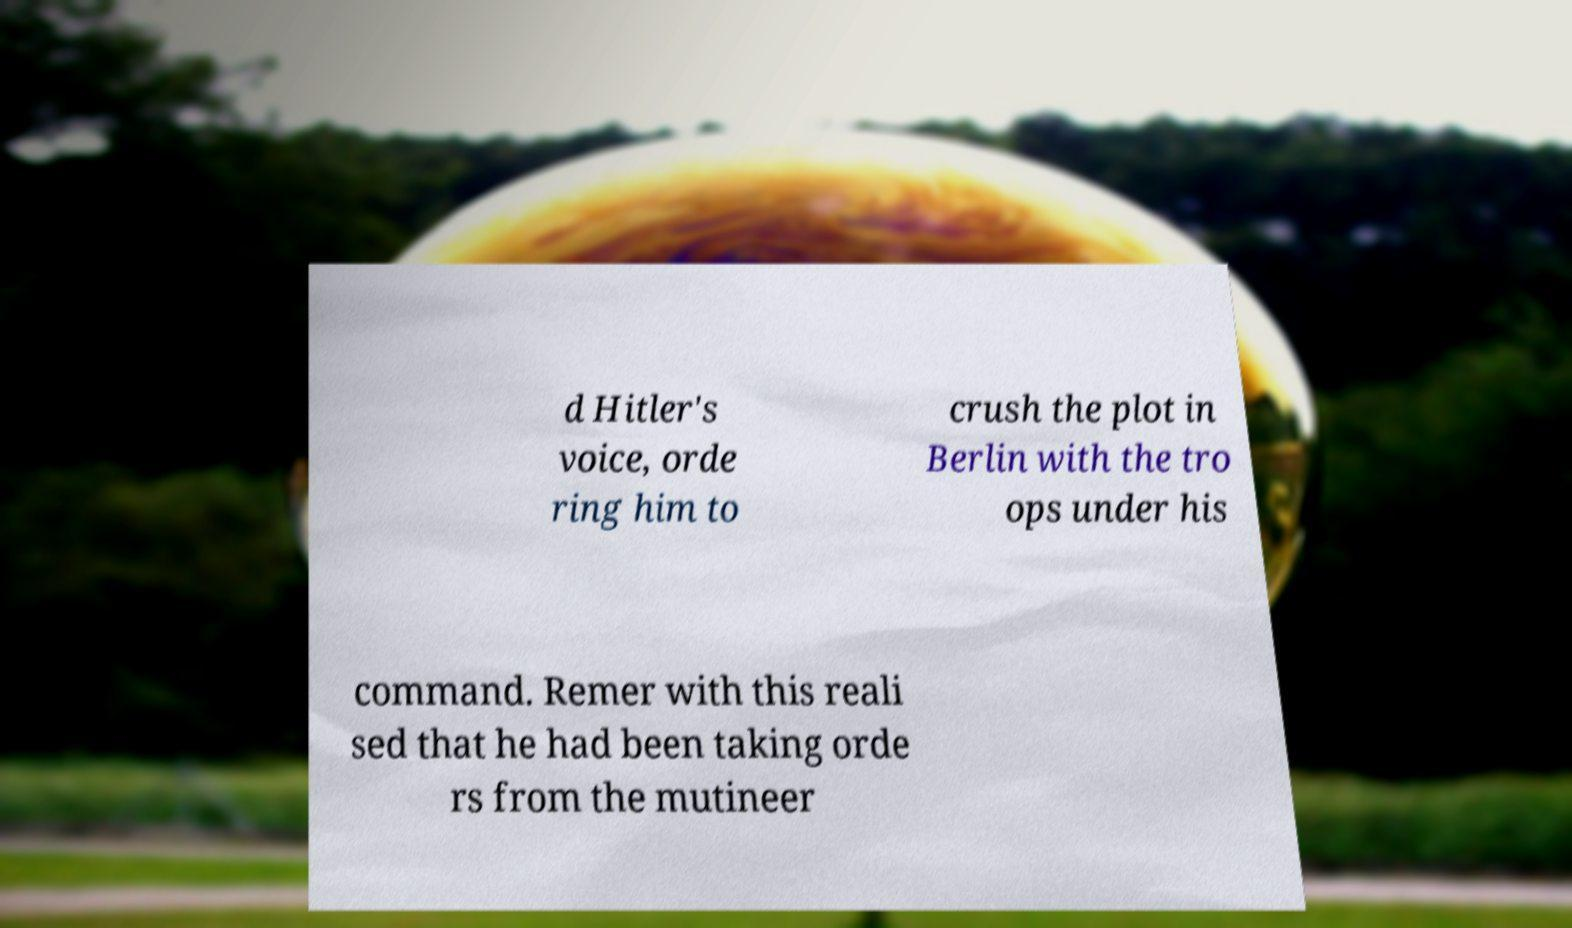What messages or text are displayed in this image? I need them in a readable, typed format. d Hitler's voice, orde ring him to crush the plot in Berlin with the tro ops under his command. Remer with this reali sed that he had been taking orde rs from the mutineer 